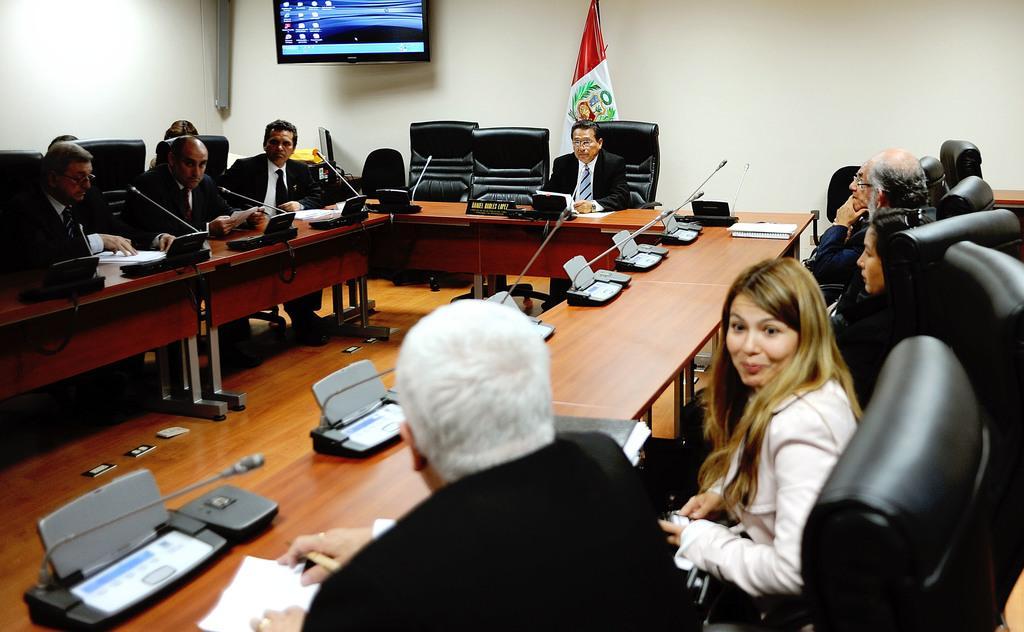In one or two sentences, can you explain what this image depicts? There are many people sitting in a room around the table which is in U shape. There is a person in the center with a coat, shirt and a tie. Behind this person there is a flag which is in red and white colour. There is a wall, to this wall a television is attached to it. In Front of every man and woman who is sitting around this U shaped table, there is a microphone for them to speak. They are sitting in a black chairs. 